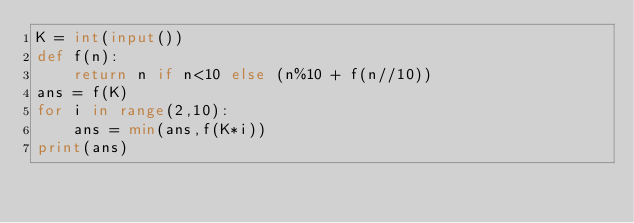Convert code to text. <code><loc_0><loc_0><loc_500><loc_500><_Python_>K = int(input())
def f(n):
    return n if n<10 else (n%10 + f(n//10))
ans = f(K)
for i in range(2,10):
    ans = min(ans,f(K*i))
print(ans)</code> 